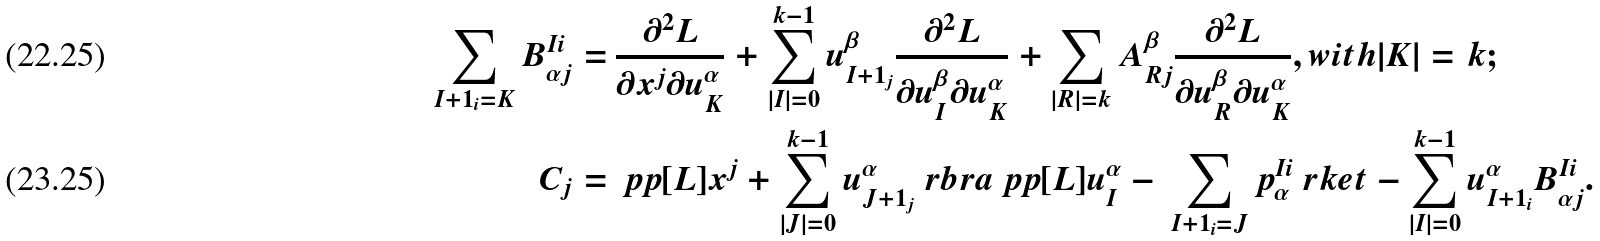Convert formula to latex. <formula><loc_0><loc_0><loc_500><loc_500>\sum _ { I + 1 _ { i } = K } B ^ { I i } _ { \alpha j } = \, & \frac { \partial ^ { 2 } L } { \partial x ^ { j } \partial u ^ { \alpha } _ { K } } + \sum _ { | I | = 0 } ^ { k - 1 } u ^ { \beta } _ { I + 1 _ { j } } \frac { \partial ^ { 2 } L } { \partial u ^ { \beta } _ { I } \partial u ^ { \alpha } _ { K } } + \sum _ { | R | = k } A ^ { \beta } _ { R j } \frac { \partial ^ { 2 } L } { \partial u ^ { \beta } _ { R } \partial u ^ { \alpha } _ { K } } , w i t h | K | = k ; \\ C _ { j } = \, & \ p p [ L ] { x ^ { j } } + \sum _ { | J | = 0 } ^ { k - 1 } u ^ { \alpha } _ { J + 1 _ { j } } \ r b r a \ p p [ L ] { u ^ { \alpha } _ { I } } - \, \sum _ { I + 1 _ { i } = J } p ^ { I i } _ { \alpha } \ r k e t - \sum _ { | I | = 0 } ^ { k - 1 } u ^ { \alpha } _ { I + 1 _ { i } } B ^ { I i } _ { \alpha j } .</formula> 